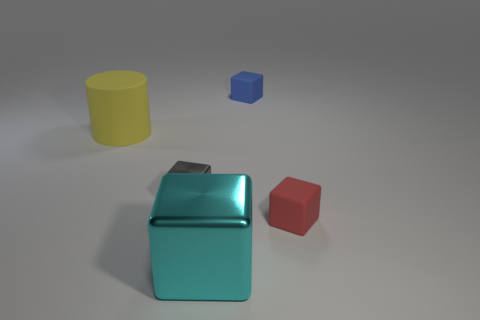Subtract all red cubes. How many cubes are left? 3 Add 1 large gray cubes. How many objects exist? 6 Subtract all brown cubes. Subtract all green spheres. How many cubes are left? 4 Subtract all blocks. How many objects are left? 1 Subtract all gray things. Subtract all cyan objects. How many objects are left? 3 Add 4 big yellow objects. How many big yellow objects are left? 5 Add 4 large purple cylinders. How many large purple cylinders exist? 4 Subtract 0 blue cylinders. How many objects are left? 5 